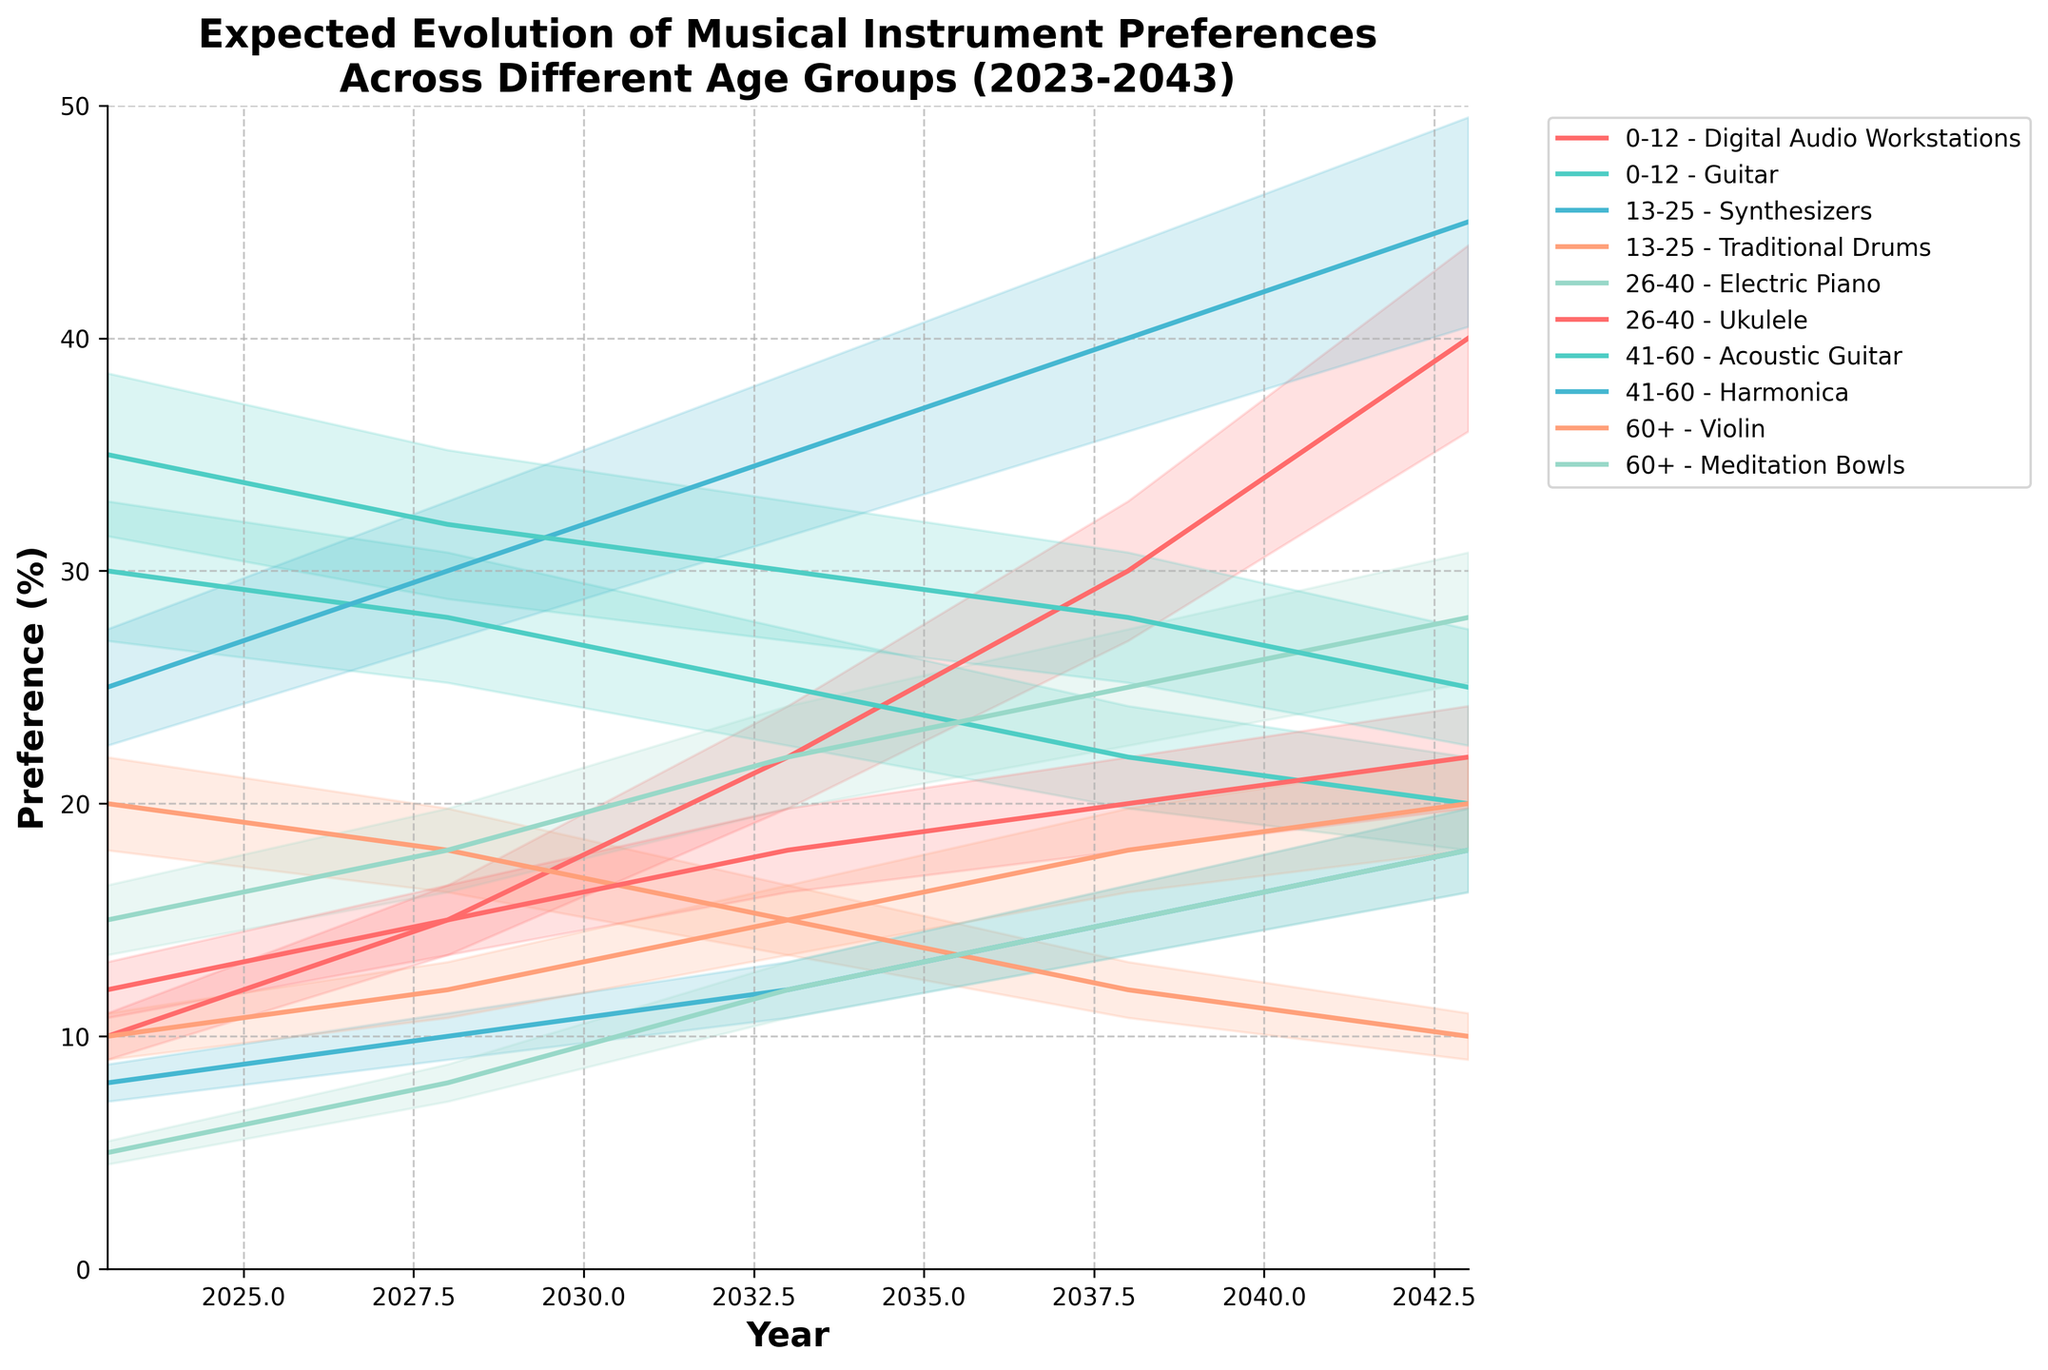What's the title of the figure? The title is clearly labeled at the top of the figure in bold text.
Answer: Expected Evolution of Musical Instrument Preferences Across Different Age Groups (2023-2043) Which age group has the highest preference for Digital Audio Workstations (DAWs) in 2043? By looking at the line representing Digital Audio Workstations for the 0-12 age group, it reaches up to 40% in 2043.
Answer: 0-12 What is the trend for preference in Guitar among the 0-12 age group over the years? The line for Guitar in the 0-12 age group is decreasing from 30% in 2023 to 20% in 2043.
Answer: Decreasing Compare the preferences between Synthesizers and Traditional Drums for the 13-25 age group in 2033. Which one is higher? By examining the lines for Synthesizers and Traditional Drums in the 13-25 age group by the year 2033, Synthesizers reach 35%, while Traditional Drums reach 15%. Thus, Synthesizers are higher.
Answer: Synthesizers Which instrument shows the steepest increase in preference according to the chart? By comparing the slopes of the lines, Digital Audio Workstations (0-12 age group) show the steepest increase, going from 10% in 2023 to 40% in 2043.
Answer: Digital Audio Workstations What is the difference in preference for Electric Piano between 2028 and 2038 for the 26-40 age group? In 2028, the preference is 18%, and in 2038, it is 25%. The difference is 25% - 18% = 7%.
Answer: 7% Which age group shows a steady decrease in the preference for Traditional Drums? The 13-25 age group shows a steady decrease in the preference for Traditional Drums, from 20% in 2023 to 10% in 2043.
Answer: 13-25 Calculate the average preference for Ukulele in the 26-40 age group over the years shown. The values for the Ukulele preference in the 26-40 age group over the years are 12%, 15%, 18%, 20%, and 22%. The average is (12 + 15 + 18 + 20 + 22) / 5 = 17.4%.
Answer: 17.4% Among the instruments for the 41-60 age group, which has a higher preference in 2038? Looking at the lines for Acoustic Guitar and Harmonica in the 41-60 age group by 2038, Acoustic Guitar is at 28%, while Harmonica is at 15%. Thus, Acoustic Guitar has a higher preference.
Answer: Acoustic Guitar 